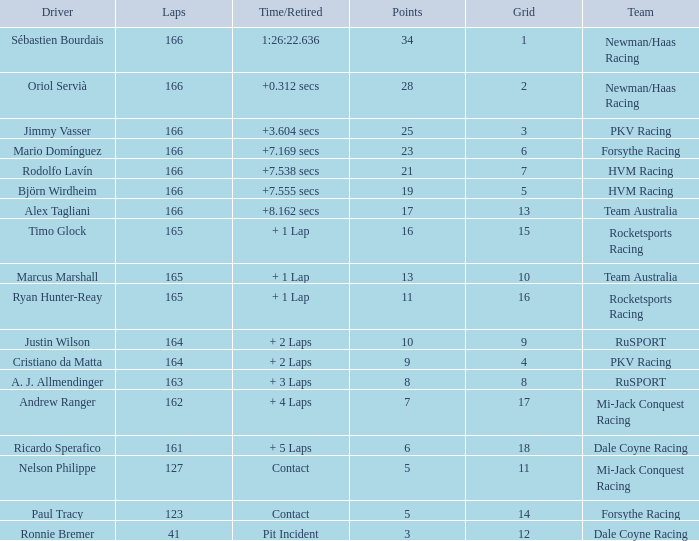Driver Ricardo Sperafico has what as his average laps? 161.0. 